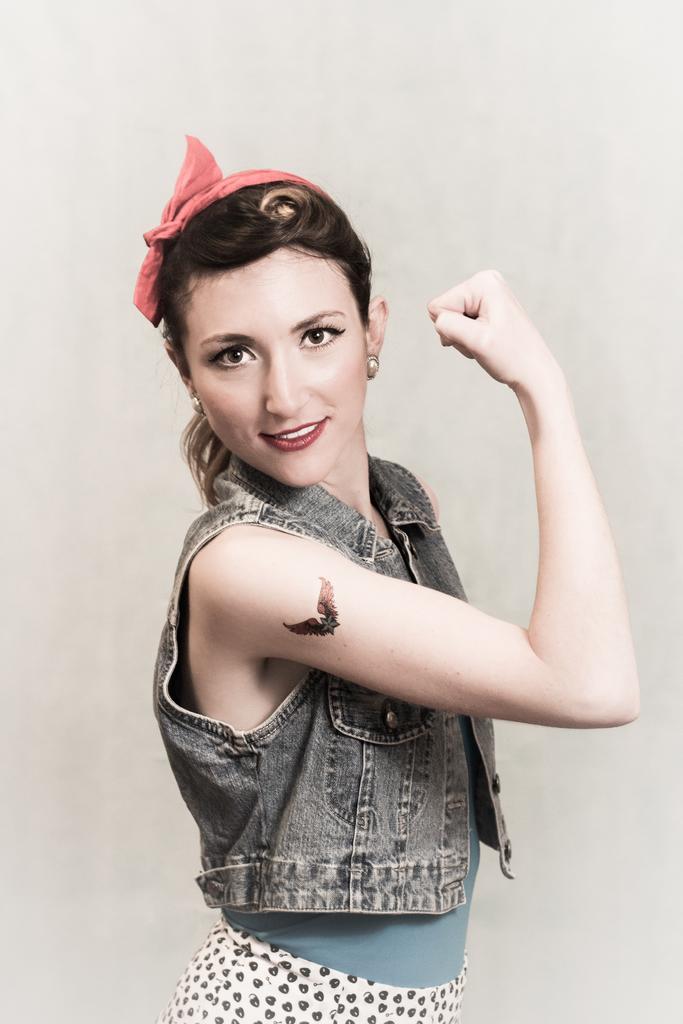Can you describe this image briefly? In this image we can see a woman and she is smiling. We can see a tattoo on her hand. There is a white background. 